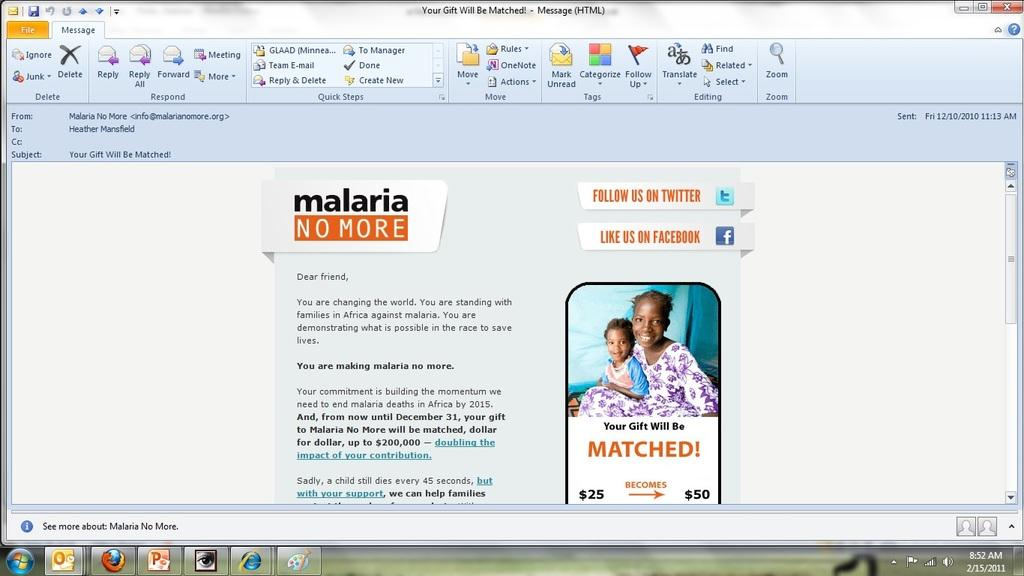<image>
Present a compact description of the photo's key features. A computer monitor which features a webpage that says "malaria no more". 